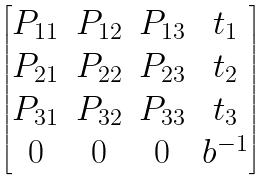<formula> <loc_0><loc_0><loc_500><loc_500>\begin{bmatrix} P _ { 1 1 } & P _ { 1 2 } & P _ { 1 3 } & t _ { 1 } \\ P _ { 2 1 } & P _ { 2 2 } & P _ { 2 3 } & t _ { 2 } \\ P _ { 3 1 } & P _ { 3 2 } & P _ { 3 3 } & t _ { 3 } \\ 0 & 0 & 0 & b ^ { - 1 } \end{bmatrix}</formula> 